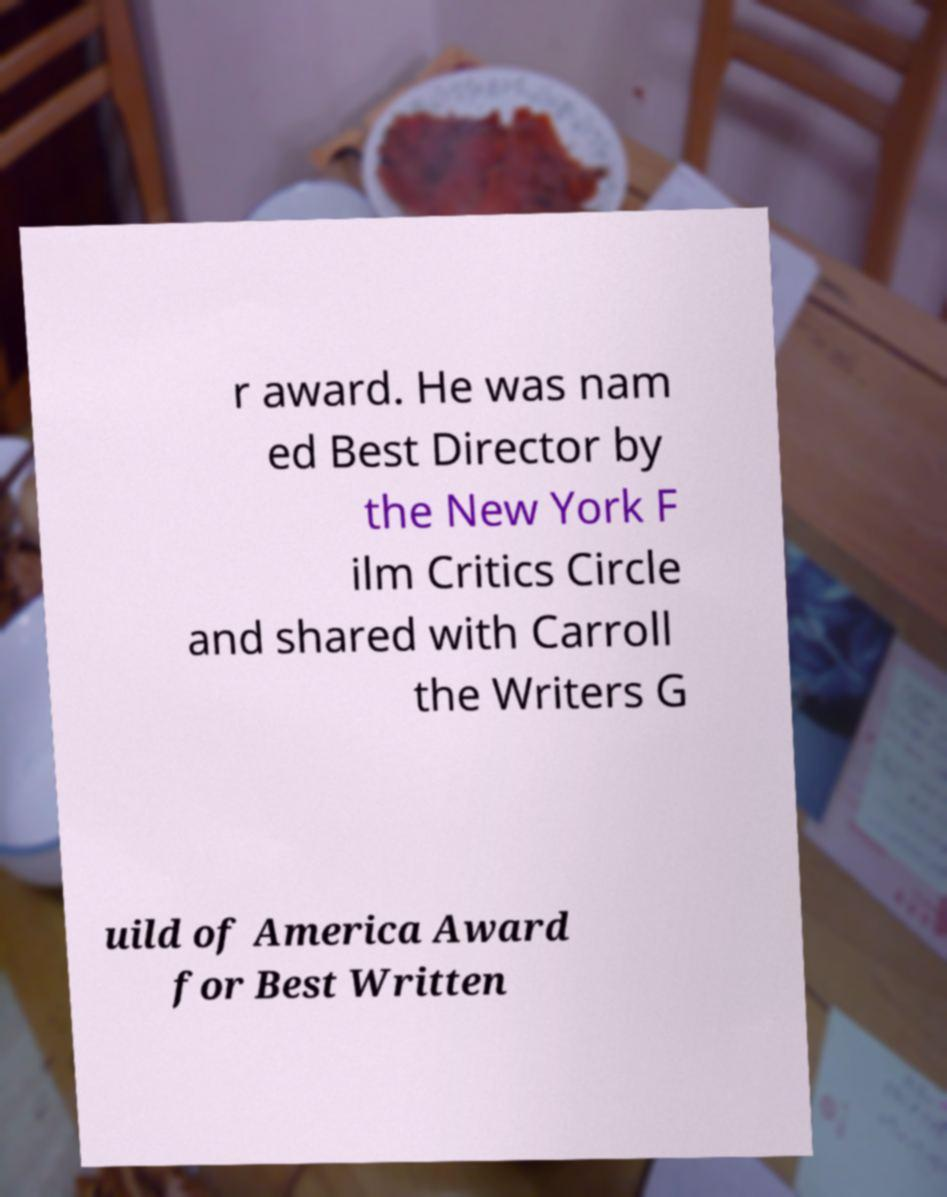I need the written content from this picture converted into text. Can you do that? r award. He was nam ed Best Director by the New York F ilm Critics Circle and shared with Carroll the Writers G uild of America Award for Best Written 